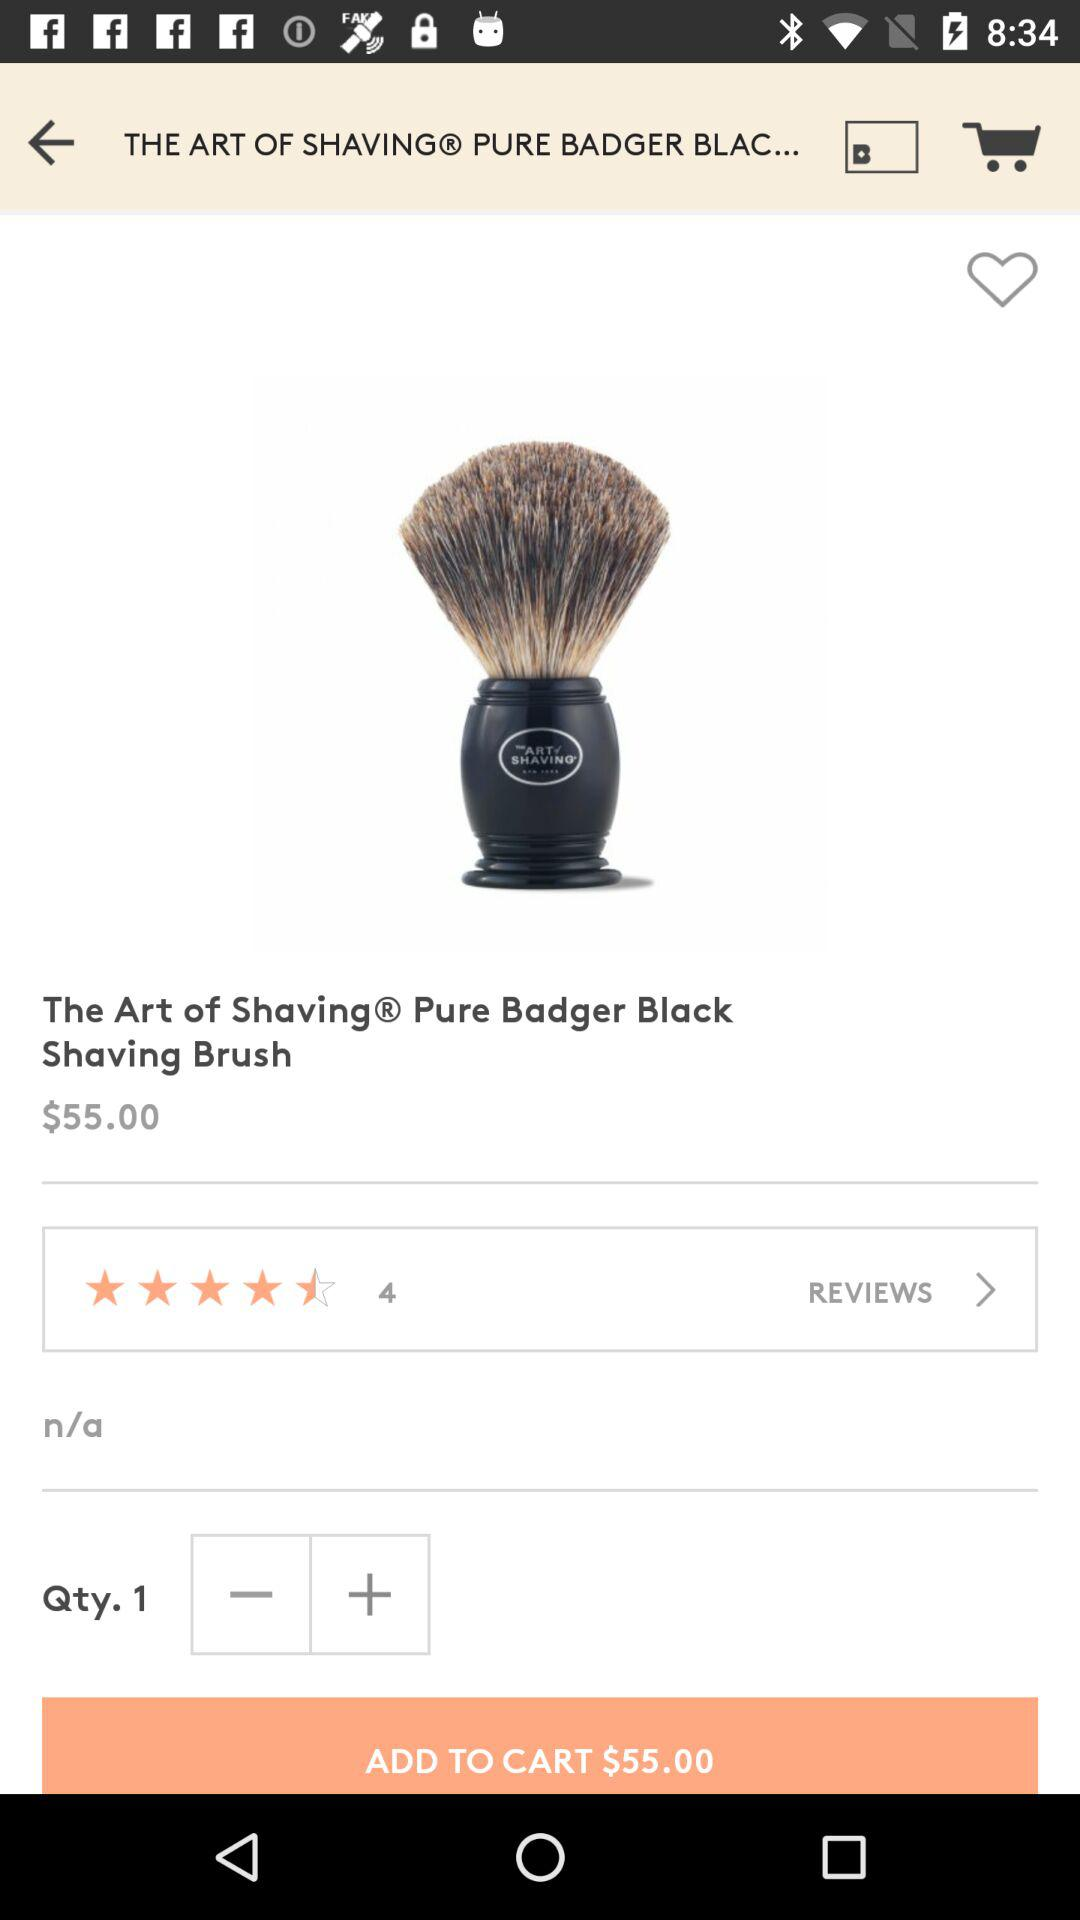What is the quantity of a pure badger black shaving brush? The quantity is 1. 